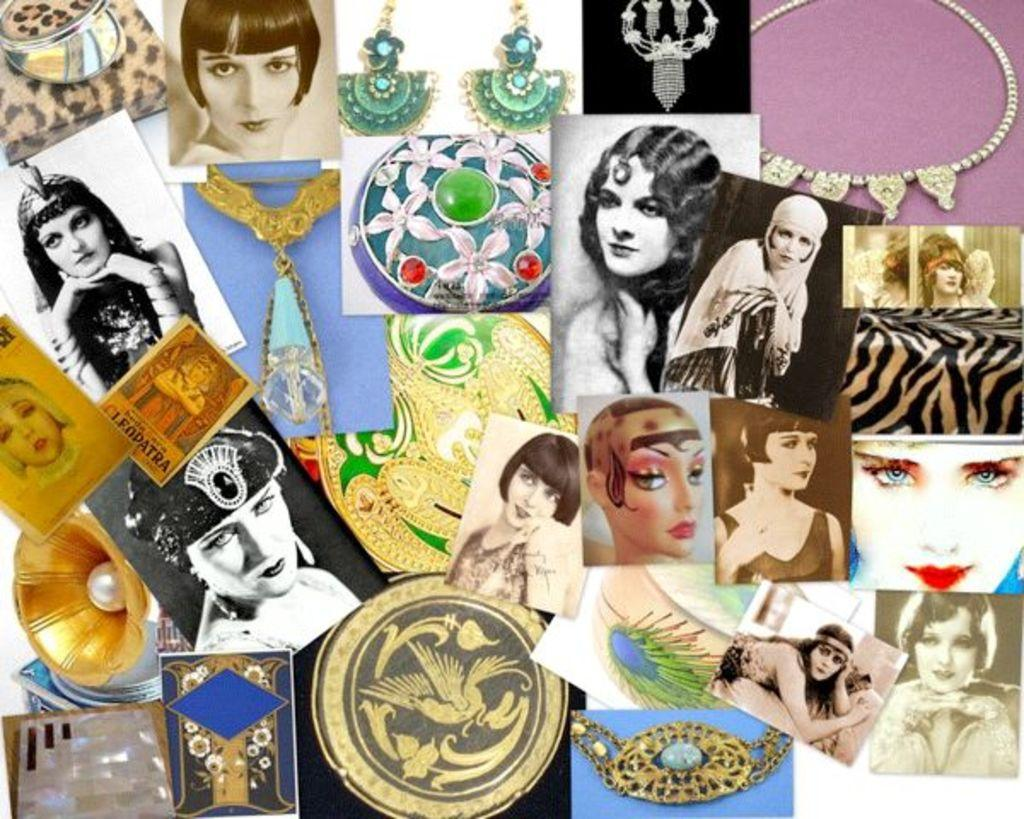What is the main object in the image? There is a board in the image. What is displayed on the board? The board contains photos of a woman and ornaments. What type of texture can be seen on the cave walls in the image? There is no cave present in the image; it features a board with photos of a woman and ornaments. 